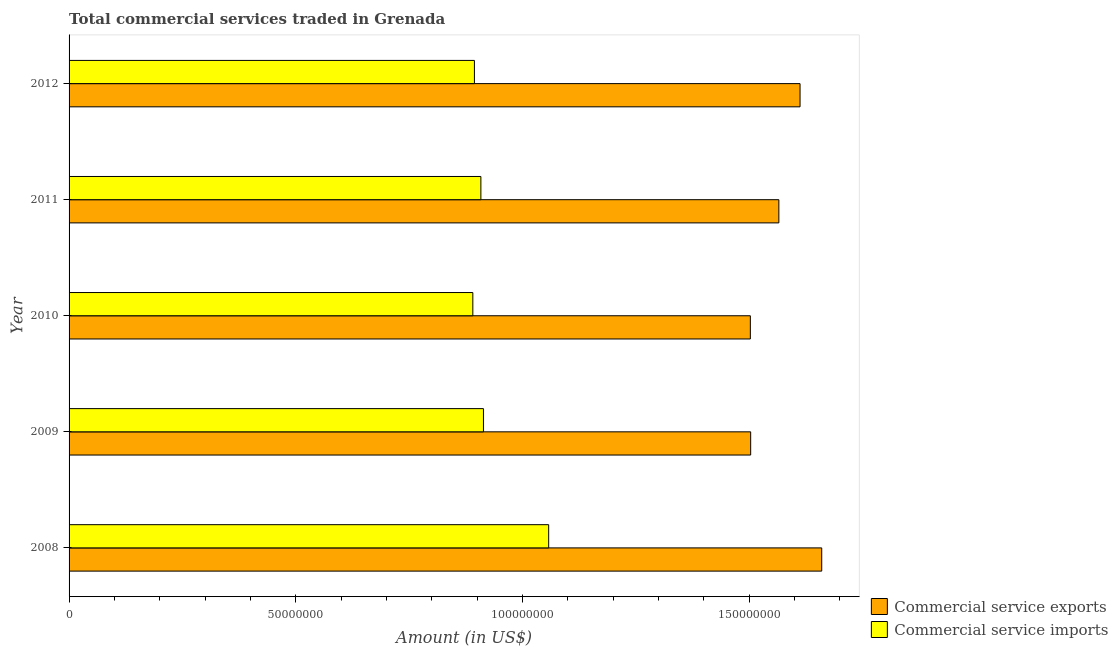How many different coloured bars are there?
Give a very brief answer. 2. Are the number of bars on each tick of the Y-axis equal?
Offer a very short reply. Yes. How many bars are there on the 4th tick from the bottom?
Provide a succinct answer. 2. What is the amount of commercial service exports in 2012?
Your response must be concise. 1.61e+08. Across all years, what is the maximum amount of commercial service imports?
Keep it short and to the point. 1.06e+08. Across all years, what is the minimum amount of commercial service imports?
Your response must be concise. 8.90e+07. In which year was the amount of commercial service exports minimum?
Your response must be concise. 2010. What is the total amount of commercial service imports in the graph?
Give a very brief answer. 4.66e+08. What is the difference between the amount of commercial service imports in 2009 and that in 2010?
Make the answer very short. 2.35e+06. What is the difference between the amount of commercial service exports in 2009 and the amount of commercial service imports in 2012?
Your answer should be very brief. 6.09e+07. What is the average amount of commercial service exports per year?
Your answer should be very brief. 1.57e+08. In the year 2009, what is the difference between the amount of commercial service imports and amount of commercial service exports?
Provide a short and direct response. -5.89e+07. In how many years, is the amount of commercial service exports greater than 150000000 US$?
Your response must be concise. 5. Is the amount of commercial service imports in 2008 less than that in 2010?
Your answer should be very brief. No. What is the difference between the highest and the second highest amount of commercial service imports?
Give a very brief answer. 1.44e+07. What is the difference between the highest and the lowest amount of commercial service exports?
Keep it short and to the point. 1.57e+07. In how many years, is the amount of commercial service exports greater than the average amount of commercial service exports taken over all years?
Ensure brevity in your answer.  2. What does the 1st bar from the top in 2010 represents?
Offer a very short reply. Commercial service imports. What does the 1st bar from the bottom in 2009 represents?
Give a very brief answer. Commercial service exports. How many bars are there?
Ensure brevity in your answer.  10. Are the values on the major ticks of X-axis written in scientific E-notation?
Offer a very short reply. No. Does the graph contain grids?
Offer a terse response. No. Where does the legend appear in the graph?
Make the answer very short. Bottom right. How are the legend labels stacked?
Provide a succinct answer. Vertical. What is the title of the graph?
Offer a very short reply. Total commercial services traded in Grenada. Does "Secondary Education" appear as one of the legend labels in the graph?
Your answer should be compact. No. What is the Amount (in US$) of Commercial service exports in 2008?
Make the answer very short. 1.66e+08. What is the Amount (in US$) of Commercial service imports in 2008?
Your answer should be compact. 1.06e+08. What is the Amount (in US$) of Commercial service exports in 2009?
Your answer should be compact. 1.50e+08. What is the Amount (in US$) in Commercial service imports in 2009?
Give a very brief answer. 9.14e+07. What is the Amount (in US$) in Commercial service exports in 2010?
Your answer should be compact. 1.50e+08. What is the Amount (in US$) of Commercial service imports in 2010?
Keep it short and to the point. 8.90e+07. What is the Amount (in US$) of Commercial service exports in 2011?
Give a very brief answer. 1.57e+08. What is the Amount (in US$) of Commercial service imports in 2011?
Offer a very short reply. 9.08e+07. What is the Amount (in US$) in Commercial service exports in 2012?
Ensure brevity in your answer.  1.61e+08. What is the Amount (in US$) of Commercial service imports in 2012?
Give a very brief answer. 8.94e+07. Across all years, what is the maximum Amount (in US$) in Commercial service exports?
Your answer should be compact. 1.66e+08. Across all years, what is the maximum Amount (in US$) of Commercial service imports?
Give a very brief answer. 1.06e+08. Across all years, what is the minimum Amount (in US$) of Commercial service exports?
Offer a very short reply. 1.50e+08. Across all years, what is the minimum Amount (in US$) in Commercial service imports?
Provide a short and direct response. 8.90e+07. What is the total Amount (in US$) of Commercial service exports in the graph?
Ensure brevity in your answer.  7.84e+08. What is the total Amount (in US$) in Commercial service imports in the graph?
Provide a succinct answer. 4.66e+08. What is the difference between the Amount (in US$) of Commercial service exports in 2008 and that in 2009?
Your response must be concise. 1.57e+07. What is the difference between the Amount (in US$) of Commercial service imports in 2008 and that in 2009?
Give a very brief answer. 1.44e+07. What is the difference between the Amount (in US$) of Commercial service exports in 2008 and that in 2010?
Your answer should be very brief. 1.57e+07. What is the difference between the Amount (in US$) in Commercial service imports in 2008 and that in 2010?
Keep it short and to the point. 1.67e+07. What is the difference between the Amount (in US$) in Commercial service exports in 2008 and that in 2011?
Make the answer very short. 9.45e+06. What is the difference between the Amount (in US$) in Commercial service imports in 2008 and that in 2011?
Your answer should be compact. 1.50e+07. What is the difference between the Amount (in US$) in Commercial service exports in 2008 and that in 2012?
Give a very brief answer. 4.78e+06. What is the difference between the Amount (in US$) of Commercial service imports in 2008 and that in 2012?
Provide a short and direct response. 1.64e+07. What is the difference between the Amount (in US$) of Commercial service exports in 2009 and that in 2010?
Provide a succinct answer. 7.10e+04. What is the difference between the Amount (in US$) of Commercial service imports in 2009 and that in 2010?
Provide a succinct answer. 2.35e+06. What is the difference between the Amount (in US$) of Commercial service exports in 2009 and that in 2011?
Provide a succinct answer. -6.22e+06. What is the difference between the Amount (in US$) of Commercial service imports in 2009 and that in 2011?
Offer a terse response. 5.72e+05. What is the difference between the Amount (in US$) in Commercial service exports in 2009 and that in 2012?
Keep it short and to the point. -1.09e+07. What is the difference between the Amount (in US$) of Commercial service imports in 2009 and that in 2012?
Give a very brief answer. 1.99e+06. What is the difference between the Amount (in US$) of Commercial service exports in 2010 and that in 2011?
Your answer should be very brief. -6.29e+06. What is the difference between the Amount (in US$) in Commercial service imports in 2010 and that in 2011?
Give a very brief answer. -1.77e+06. What is the difference between the Amount (in US$) of Commercial service exports in 2010 and that in 2012?
Give a very brief answer. -1.10e+07. What is the difference between the Amount (in US$) of Commercial service imports in 2010 and that in 2012?
Keep it short and to the point. -3.52e+05. What is the difference between the Amount (in US$) of Commercial service exports in 2011 and that in 2012?
Ensure brevity in your answer.  -4.68e+06. What is the difference between the Amount (in US$) of Commercial service imports in 2011 and that in 2012?
Offer a very short reply. 1.42e+06. What is the difference between the Amount (in US$) of Commercial service exports in 2008 and the Amount (in US$) of Commercial service imports in 2009?
Offer a terse response. 7.46e+07. What is the difference between the Amount (in US$) in Commercial service exports in 2008 and the Amount (in US$) in Commercial service imports in 2010?
Provide a short and direct response. 7.69e+07. What is the difference between the Amount (in US$) in Commercial service exports in 2008 and the Amount (in US$) in Commercial service imports in 2011?
Provide a succinct answer. 7.52e+07. What is the difference between the Amount (in US$) in Commercial service exports in 2008 and the Amount (in US$) in Commercial service imports in 2012?
Ensure brevity in your answer.  7.66e+07. What is the difference between the Amount (in US$) of Commercial service exports in 2009 and the Amount (in US$) of Commercial service imports in 2010?
Provide a short and direct response. 6.13e+07. What is the difference between the Amount (in US$) in Commercial service exports in 2009 and the Amount (in US$) in Commercial service imports in 2011?
Make the answer very short. 5.95e+07. What is the difference between the Amount (in US$) of Commercial service exports in 2009 and the Amount (in US$) of Commercial service imports in 2012?
Give a very brief answer. 6.09e+07. What is the difference between the Amount (in US$) in Commercial service exports in 2010 and the Amount (in US$) in Commercial service imports in 2011?
Make the answer very short. 5.94e+07. What is the difference between the Amount (in US$) in Commercial service exports in 2010 and the Amount (in US$) in Commercial service imports in 2012?
Your response must be concise. 6.09e+07. What is the difference between the Amount (in US$) in Commercial service exports in 2011 and the Amount (in US$) in Commercial service imports in 2012?
Your answer should be very brief. 6.71e+07. What is the average Amount (in US$) of Commercial service exports per year?
Ensure brevity in your answer.  1.57e+08. What is the average Amount (in US$) of Commercial service imports per year?
Keep it short and to the point. 9.33e+07. In the year 2008, what is the difference between the Amount (in US$) in Commercial service exports and Amount (in US$) in Commercial service imports?
Ensure brevity in your answer.  6.02e+07. In the year 2009, what is the difference between the Amount (in US$) in Commercial service exports and Amount (in US$) in Commercial service imports?
Keep it short and to the point. 5.89e+07. In the year 2010, what is the difference between the Amount (in US$) in Commercial service exports and Amount (in US$) in Commercial service imports?
Give a very brief answer. 6.12e+07. In the year 2011, what is the difference between the Amount (in US$) of Commercial service exports and Amount (in US$) of Commercial service imports?
Give a very brief answer. 6.57e+07. In the year 2012, what is the difference between the Amount (in US$) in Commercial service exports and Amount (in US$) in Commercial service imports?
Provide a short and direct response. 7.18e+07. What is the ratio of the Amount (in US$) in Commercial service exports in 2008 to that in 2009?
Your answer should be compact. 1.1. What is the ratio of the Amount (in US$) of Commercial service imports in 2008 to that in 2009?
Ensure brevity in your answer.  1.16. What is the ratio of the Amount (in US$) in Commercial service exports in 2008 to that in 2010?
Ensure brevity in your answer.  1.1. What is the ratio of the Amount (in US$) of Commercial service imports in 2008 to that in 2010?
Make the answer very short. 1.19. What is the ratio of the Amount (in US$) in Commercial service exports in 2008 to that in 2011?
Your answer should be very brief. 1.06. What is the ratio of the Amount (in US$) in Commercial service imports in 2008 to that in 2011?
Make the answer very short. 1.16. What is the ratio of the Amount (in US$) in Commercial service exports in 2008 to that in 2012?
Make the answer very short. 1.03. What is the ratio of the Amount (in US$) in Commercial service imports in 2008 to that in 2012?
Your response must be concise. 1.18. What is the ratio of the Amount (in US$) in Commercial service exports in 2009 to that in 2010?
Give a very brief answer. 1. What is the ratio of the Amount (in US$) of Commercial service imports in 2009 to that in 2010?
Keep it short and to the point. 1.03. What is the ratio of the Amount (in US$) in Commercial service exports in 2009 to that in 2011?
Offer a terse response. 0.96. What is the ratio of the Amount (in US$) of Commercial service imports in 2009 to that in 2011?
Offer a terse response. 1.01. What is the ratio of the Amount (in US$) in Commercial service exports in 2009 to that in 2012?
Your response must be concise. 0.93. What is the ratio of the Amount (in US$) in Commercial service imports in 2009 to that in 2012?
Give a very brief answer. 1.02. What is the ratio of the Amount (in US$) in Commercial service exports in 2010 to that in 2011?
Your answer should be compact. 0.96. What is the ratio of the Amount (in US$) in Commercial service imports in 2010 to that in 2011?
Keep it short and to the point. 0.98. What is the ratio of the Amount (in US$) of Commercial service exports in 2010 to that in 2012?
Make the answer very short. 0.93. What is the ratio of the Amount (in US$) in Commercial service imports in 2010 to that in 2012?
Keep it short and to the point. 1. What is the ratio of the Amount (in US$) in Commercial service imports in 2011 to that in 2012?
Provide a succinct answer. 1.02. What is the difference between the highest and the second highest Amount (in US$) in Commercial service exports?
Provide a short and direct response. 4.78e+06. What is the difference between the highest and the second highest Amount (in US$) of Commercial service imports?
Make the answer very short. 1.44e+07. What is the difference between the highest and the lowest Amount (in US$) of Commercial service exports?
Your answer should be very brief. 1.57e+07. What is the difference between the highest and the lowest Amount (in US$) in Commercial service imports?
Provide a succinct answer. 1.67e+07. 